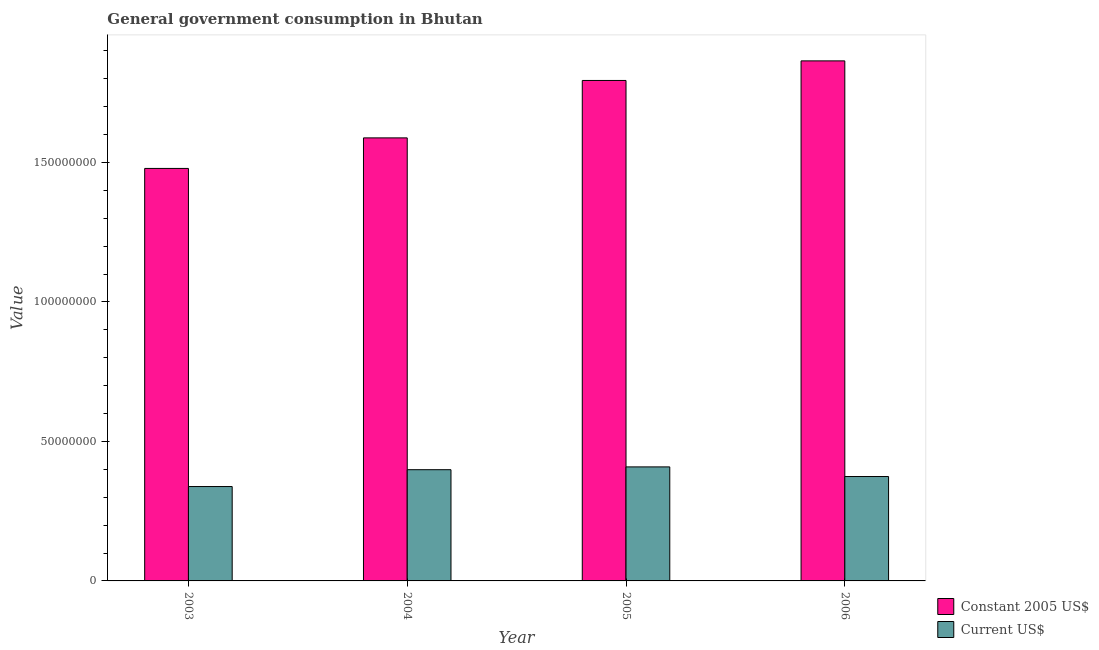How many different coloured bars are there?
Offer a terse response. 2. How many groups of bars are there?
Offer a terse response. 4. Are the number of bars on each tick of the X-axis equal?
Your answer should be compact. Yes. How many bars are there on the 3rd tick from the left?
Make the answer very short. 2. In how many cases, is the number of bars for a given year not equal to the number of legend labels?
Offer a very short reply. 0. What is the value consumed in current us$ in 2006?
Keep it short and to the point. 3.74e+07. Across all years, what is the maximum value consumed in constant 2005 us$?
Ensure brevity in your answer.  1.86e+08. Across all years, what is the minimum value consumed in current us$?
Your response must be concise. 3.38e+07. In which year was the value consumed in current us$ maximum?
Your answer should be very brief. 2005. What is the total value consumed in current us$ in the graph?
Give a very brief answer. 1.52e+08. What is the difference between the value consumed in constant 2005 us$ in 2003 and that in 2005?
Provide a succinct answer. -3.15e+07. What is the difference between the value consumed in constant 2005 us$ in 2006 and the value consumed in current us$ in 2004?
Provide a succinct answer. 2.76e+07. What is the average value consumed in current us$ per year?
Give a very brief answer. 3.80e+07. In how many years, is the value consumed in constant 2005 us$ greater than 120000000?
Offer a very short reply. 4. What is the ratio of the value consumed in constant 2005 us$ in 2004 to that in 2006?
Your answer should be very brief. 0.85. Is the value consumed in current us$ in 2004 less than that in 2006?
Ensure brevity in your answer.  No. What is the difference between the highest and the second highest value consumed in constant 2005 us$?
Offer a terse response. 7.02e+06. What is the difference between the highest and the lowest value consumed in current us$?
Offer a very short reply. 7.04e+06. Is the sum of the value consumed in current us$ in 2003 and 2005 greater than the maximum value consumed in constant 2005 us$ across all years?
Keep it short and to the point. Yes. What does the 1st bar from the left in 2005 represents?
Your answer should be very brief. Constant 2005 US$. What does the 1st bar from the right in 2004 represents?
Give a very brief answer. Current US$. Are all the bars in the graph horizontal?
Ensure brevity in your answer.  No. How many years are there in the graph?
Make the answer very short. 4. Does the graph contain any zero values?
Your answer should be very brief. No. Does the graph contain grids?
Provide a short and direct response. No. How are the legend labels stacked?
Your response must be concise. Vertical. What is the title of the graph?
Offer a very short reply. General government consumption in Bhutan. Does "Money lenders" appear as one of the legend labels in the graph?
Your answer should be very brief. No. What is the label or title of the X-axis?
Ensure brevity in your answer.  Year. What is the label or title of the Y-axis?
Your response must be concise. Value. What is the Value of Constant 2005 US$ in 2003?
Ensure brevity in your answer.  1.48e+08. What is the Value in Current US$ in 2003?
Your answer should be compact. 3.38e+07. What is the Value in Constant 2005 US$ in 2004?
Ensure brevity in your answer.  1.59e+08. What is the Value of Current US$ in 2004?
Give a very brief answer. 3.99e+07. What is the Value in Constant 2005 US$ in 2005?
Give a very brief answer. 1.79e+08. What is the Value of Current US$ in 2005?
Provide a succinct answer. 4.09e+07. What is the Value of Constant 2005 US$ in 2006?
Your response must be concise. 1.86e+08. What is the Value of Current US$ in 2006?
Provide a succinct answer. 3.74e+07. Across all years, what is the maximum Value of Constant 2005 US$?
Your response must be concise. 1.86e+08. Across all years, what is the maximum Value of Current US$?
Your answer should be compact. 4.09e+07. Across all years, what is the minimum Value in Constant 2005 US$?
Ensure brevity in your answer.  1.48e+08. Across all years, what is the minimum Value of Current US$?
Make the answer very short. 3.38e+07. What is the total Value of Constant 2005 US$ in the graph?
Make the answer very short. 6.72e+08. What is the total Value of Current US$ in the graph?
Your response must be concise. 1.52e+08. What is the difference between the Value in Constant 2005 US$ in 2003 and that in 2004?
Offer a terse response. -1.09e+07. What is the difference between the Value in Current US$ in 2003 and that in 2004?
Provide a short and direct response. -6.04e+06. What is the difference between the Value in Constant 2005 US$ in 2003 and that in 2005?
Make the answer very short. -3.15e+07. What is the difference between the Value of Current US$ in 2003 and that in 2005?
Offer a terse response. -7.04e+06. What is the difference between the Value of Constant 2005 US$ in 2003 and that in 2006?
Your answer should be compact. -3.86e+07. What is the difference between the Value of Current US$ in 2003 and that in 2006?
Your answer should be compact. -3.59e+06. What is the difference between the Value in Constant 2005 US$ in 2004 and that in 2005?
Your response must be concise. -2.06e+07. What is the difference between the Value of Current US$ in 2004 and that in 2005?
Give a very brief answer. -1.00e+06. What is the difference between the Value in Constant 2005 US$ in 2004 and that in 2006?
Your answer should be compact. -2.76e+07. What is the difference between the Value in Current US$ in 2004 and that in 2006?
Provide a short and direct response. 2.45e+06. What is the difference between the Value in Constant 2005 US$ in 2005 and that in 2006?
Offer a very short reply. -7.02e+06. What is the difference between the Value of Current US$ in 2005 and that in 2006?
Offer a terse response. 3.45e+06. What is the difference between the Value of Constant 2005 US$ in 2003 and the Value of Current US$ in 2004?
Ensure brevity in your answer.  1.08e+08. What is the difference between the Value of Constant 2005 US$ in 2003 and the Value of Current US$ in 2005?
Provide a short and direct response. 1.07e+08. What is the difference between the Value in Constant 2005 US$ in 2003 and the Value in Current US$ in 2006?
Your answer should be very brief. 1.10e+08. What is the difference between the Value of Constant 2005 US$ in 2004 and the Value of Current US$ in 2005?
Your answer should be very brief. 1.18e+08. What is the difference between the Value of Constant 2005 US$ in 2004 and the Value of Current US$ in 2006?
Your answer should be very brief. 1.21e+08. What is the difference between the Value of Constant 2005 US$ in 2005 and the Value of Current US$ in 2006?
Your answer should be compact. 1.42e+08. What is the average Value in Constant 2005 US$ per year?
Make the answer very short. 1.68e+08. What is the average Value of Current US$ per year?
Provide a short and direct response. 3.80e+07. In the year 2003, what is the difference between the Value of Constant 2005 US$ and Value of Current US$?
Provide a short and direct response. 1.14e+08. In the year 2004, what is the difference between the Value in Constant 2005 US$ and Value in Current US$?
Offer a very short reply. 1.19e+08. In the year 2005, what is the difference between the Value in Constant 2005 US$ and Value in Current US$?
Your response must be concise. 1.39e+08. In the year 2006, what is the difference between the Value of Constant 2005 US$ and Value of Current US$?
Provide a succinct answer. 1.49e+08. What is the ratio of the Value in Constant 2005 US$ in 2003 to that in 2004?
Your answer should be compact. 0.93. What is the ratio of the Value in Current US$ in 2003 to that in 2004?
Provide a short and direct response. 0.85. What is the ratio of the Value of Constant 2005 US$ in 2003 to that in 2005?
Make the answer very short. 0.82. What is the ratio of the Value of Current US$ in 2003 to that in 2005?
Ensure brevity in your answer.  0.83. What is the ratio of the Value of Constant 2005 US$ in 2003 to that in 2006?
Provide a succinct answer. 0.79. What is the ratio of the Value in Current US$ in 2003 to that in 2006?
Provide a short and direct response. 0.9. What is the ratio of the Value of Constant 2005 US$ in 2004 to that in 2005?
Offer a very short reply. 0.89. What is the ratio of the Value of Current US$ in 2004 to that in 2005?
Your answer should be very brief. 0.98. What is the ratio of the Value of Constant 2005 US$ in 2004 to that in 2006?
Ensure brevity in your answer.  0.85. What is the ratio of the Value in Current US$ in 2004 to that in 2006?
Your response must be concise. 1.07. What is the ratio of the Value of Constant 2005 US$ in 2005 to that in 2006?
Ensure brevity in your answer.  0.96. What is the ratio of the Value in Current US$ in 2005 to that in 2006?
Make the answer very short. 1.09. What is the difference between the highest and the second highest Value of Constant 2005 US$?
Give a very brief answer. 7.02e+06. What is the difference between the highest and the second highest Value of Current US$?
Your answer should be very brief. 1.00e+06. What is the difference between the highest and the lowest Value in Constant 2005 US$?
Make the answer very short. 3.86e+07. What is the difference between the highest and the lowest Value in Current US$?
Make the answer very short. 7.04e+06. 